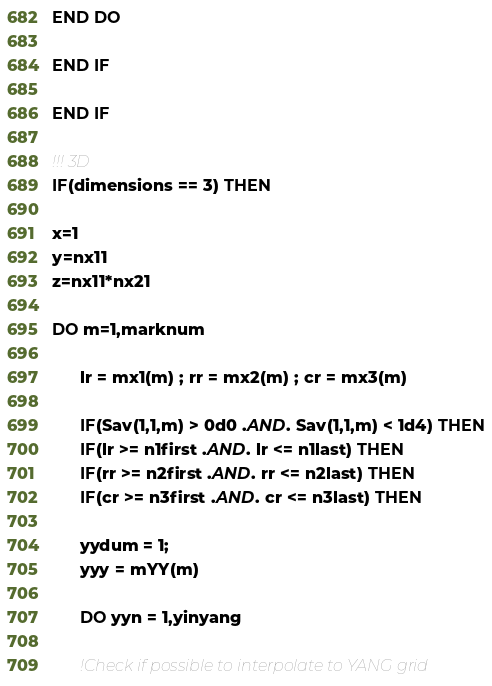<code> <loc_0><loc_0><loc_500><loc_500><_FORTRAN_>END DO
    
END IF

END IF

!!! 3D
IF(dimensions == 3) THEN

x=1
y=nx11
z=nx11*nx21

DO m=1,marknum

      lr = mx1(m) ; rr = mx2(m) ; cr = mx3(m)

      IF(Sav(1,1,m) > 0d0 .AND. Sav(1,1,m) < 1d4) THEN
      IF(lr >= n1first .AND. lr <= n1last) THEN
      IF(rr >= n2first .AND. rr <= n2last) THEN
      IF(cr >= n3first .AND. cr <= n3last) THEN

      yydum = 1;
      yyy = mYY(m)
      
      DO yyn = 1,yinyang

      !Check if possible to interpolate to YANG grid</code> 